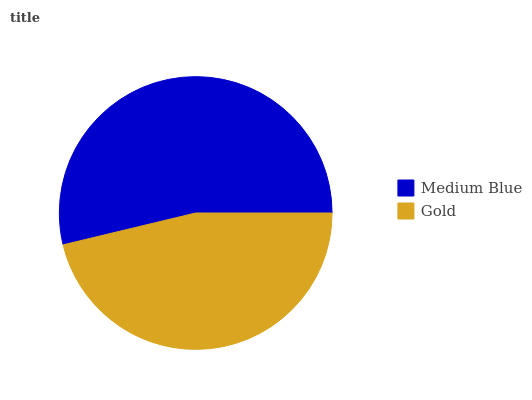Is Gold the minimum?
Answer yes or no. Yes. Is Medium Blue the maximum?
Answer yes or no. Yes. Is Gold the maximum?
Answer yes or no. No. Is Medium Blue greater than Gold?
Answer yes or no. Yes. Is Gold less than Medium Blue?
Answer yes or no. Yes. Is Gold greater than Medium Blue?
Answer yes or no. No. Is Medium Blue less than Gold?
Answer yes or no. No. Is Medium Blue the high median?
Answer yes or no. Yes. Is Gold the low median?
Answer yes or no. Yes. Is Gold the high median?
Answer yes or no. No. Is Medium Blue the low median?
Answer yes or no. No. 